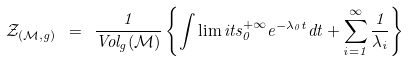Convert formula to latex. <formula><loc_0><loc_0><loc_500><loc_500>\mathcal { Z } _ { ( \mathcal { M } , g ) } \ = \ \frac { 1 } { V o l _ { g } ( \mathcal { M } ) } \left \{ \int \lim i t s _ { 0 } ^ { + \infty } e ^ { - \lambda _ { 0 } t } d t + \sum _ { i = 1 } ^ { \infty } \frac { 1 } { \lambda _ { i } } \right \}</formula> 